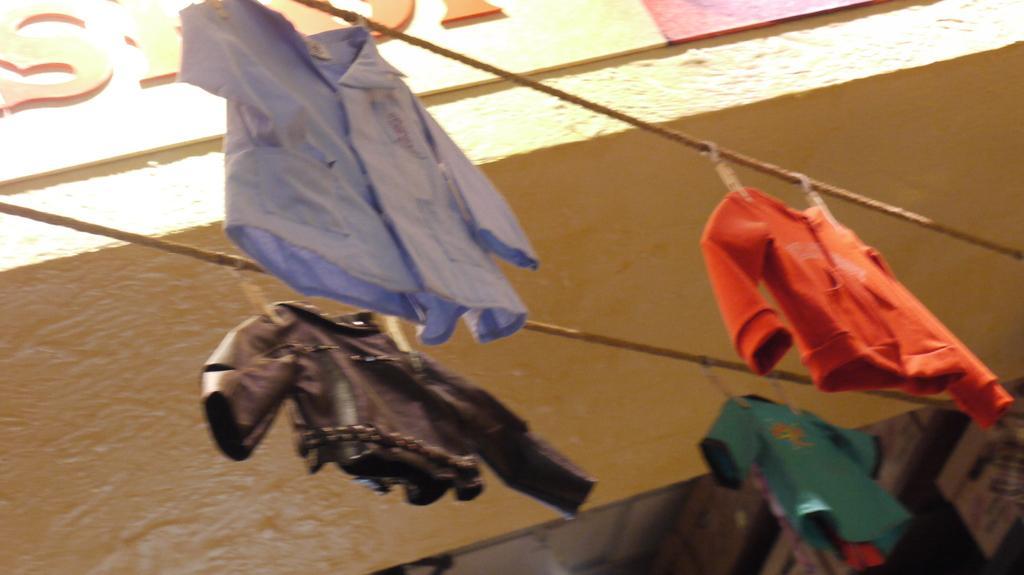Can you describe this image briefly? In this image we can see one name board attached to the building wall, two wires with some dresses attached to it, two objects attached to the ceiling and some objects attached to the wall. 